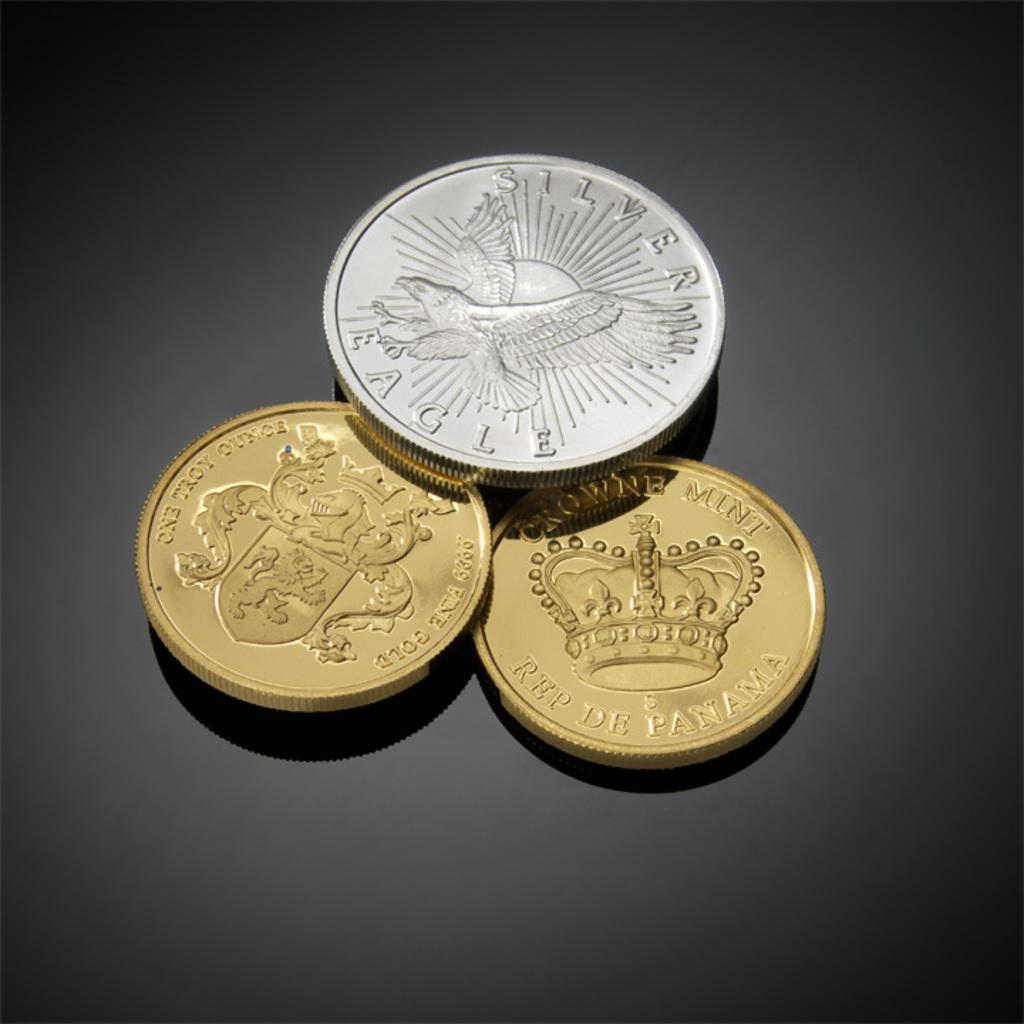<image>
Present a compact description of the photo's key features. The silver coin has the word Silver on it's face 